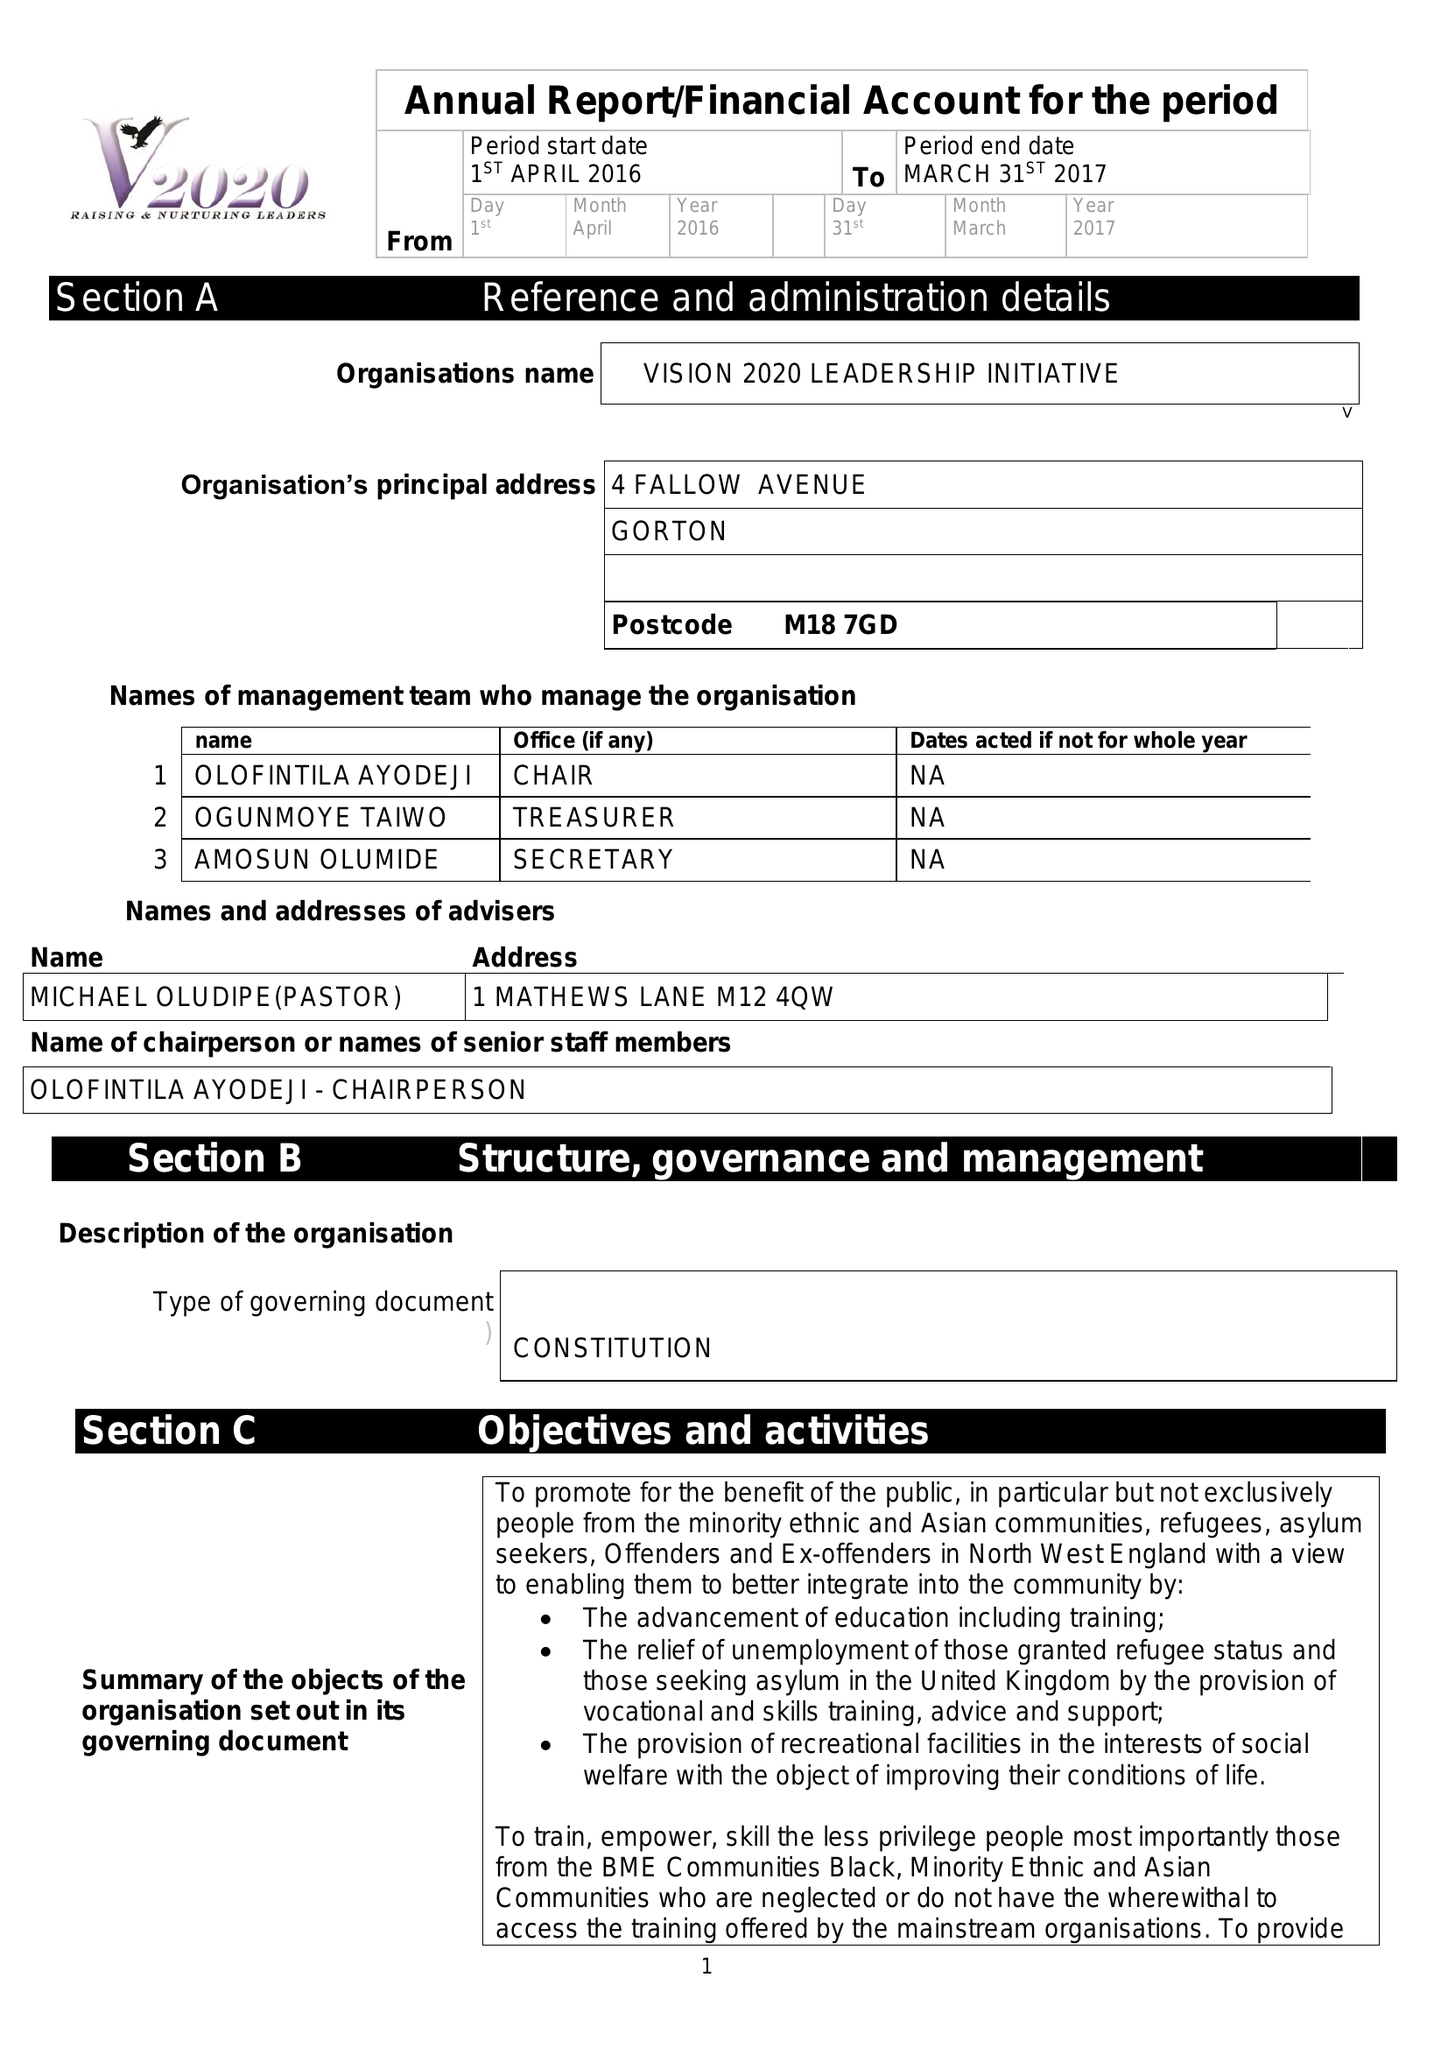What is the value for the address__post_town?
Answer the question using a single word or phrase. MANCHESTER 